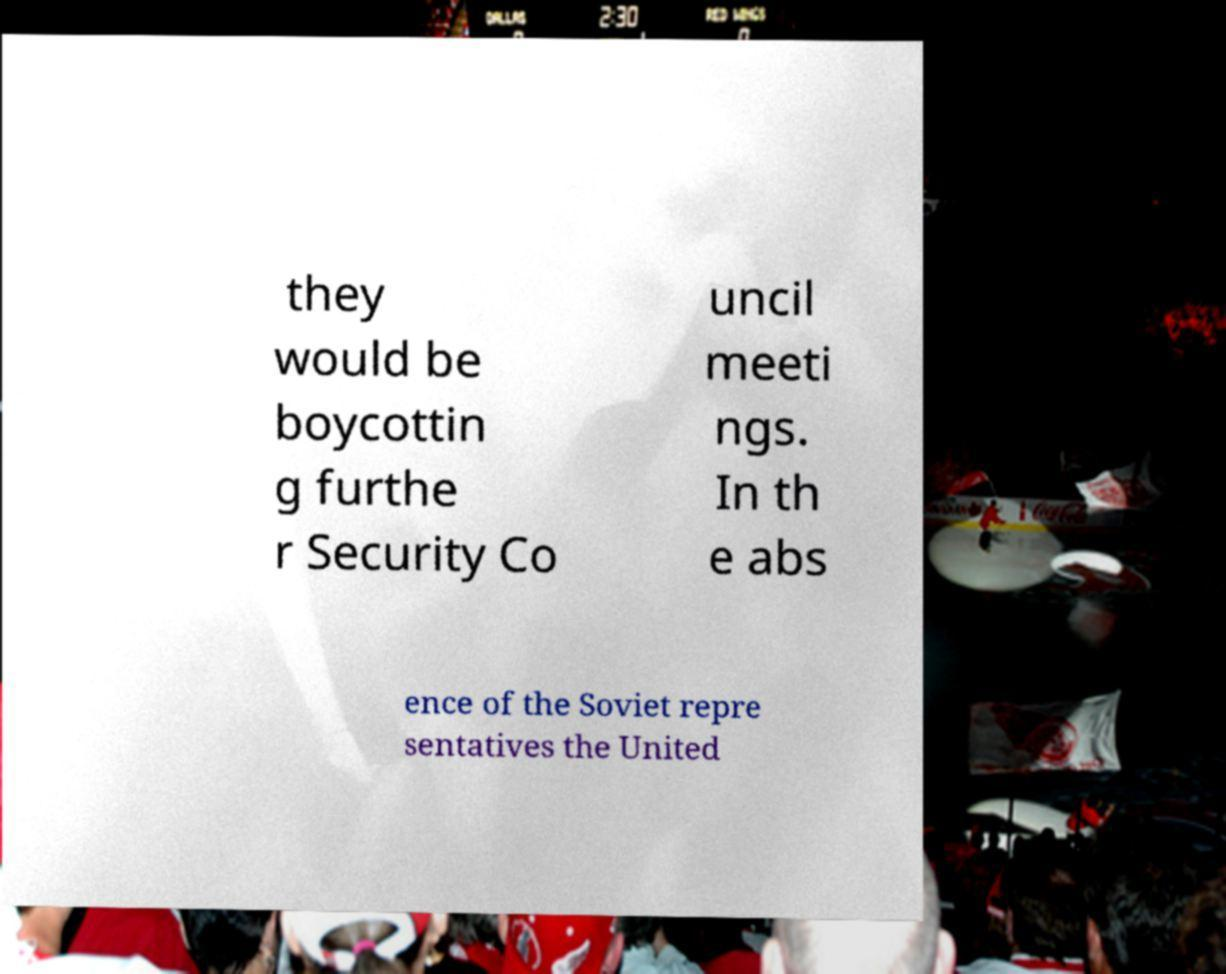Could you extract and type out the text from this image? they would be boycottin g furthe r Security Co uncil meeti ngs. In th e abs ence of the Soviet repre sentatives the United 